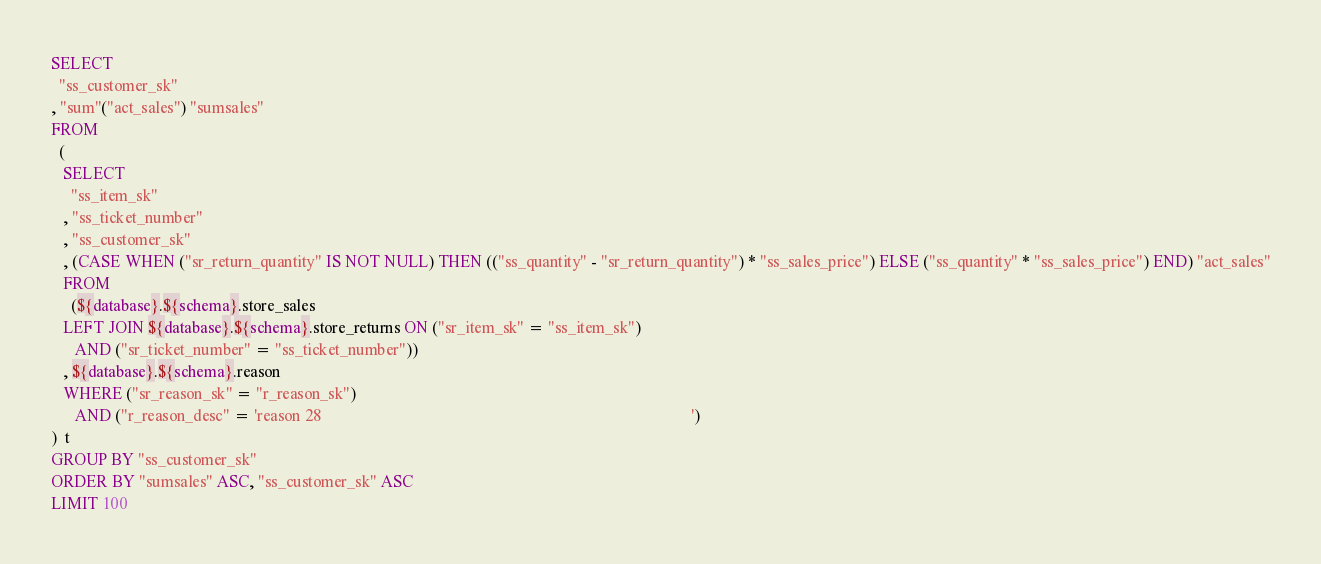<code> <loc_0><loc_0><loc_500><loc_500><_SQL_>SELECT
  "ss_customer_sk"
, "sum"("act_sales") "sumsales"
FROM
  (
   SELECT
     "ss_item_sk"
   , "ss_ticket_number"
   , "ss_customer_sk"
   , (CASE WHEN ("sr_return_quantity" IS NOT NULL) THEN (("ss_quantity" - "sr_return_quantity") * "ss_sales_price") ELSE ("ss_quantity" * "ss_sales_price") END) "act_sales"
   FROM
     (${database}.${schema}.store_sales
   LEFT JOIN ${database}.${schema}.store_returns ON ("sr_item_sk" = "ss_item_sk")
      AND ("sr_ticket_number" = "ss_ticket_number"))
   , ${database}.${schema}.reason
   WHERE ("sr_reason_sk" = "r_reason_sk")
      AND ("r_reason_desc" = 'reason 28                                                                                           ')
)  t
GROUP BY "ss_customer_sk"
ORDER BY "sumsales" ASC, "ss_customer_sk" ASC
LIMIT 100
</code> 